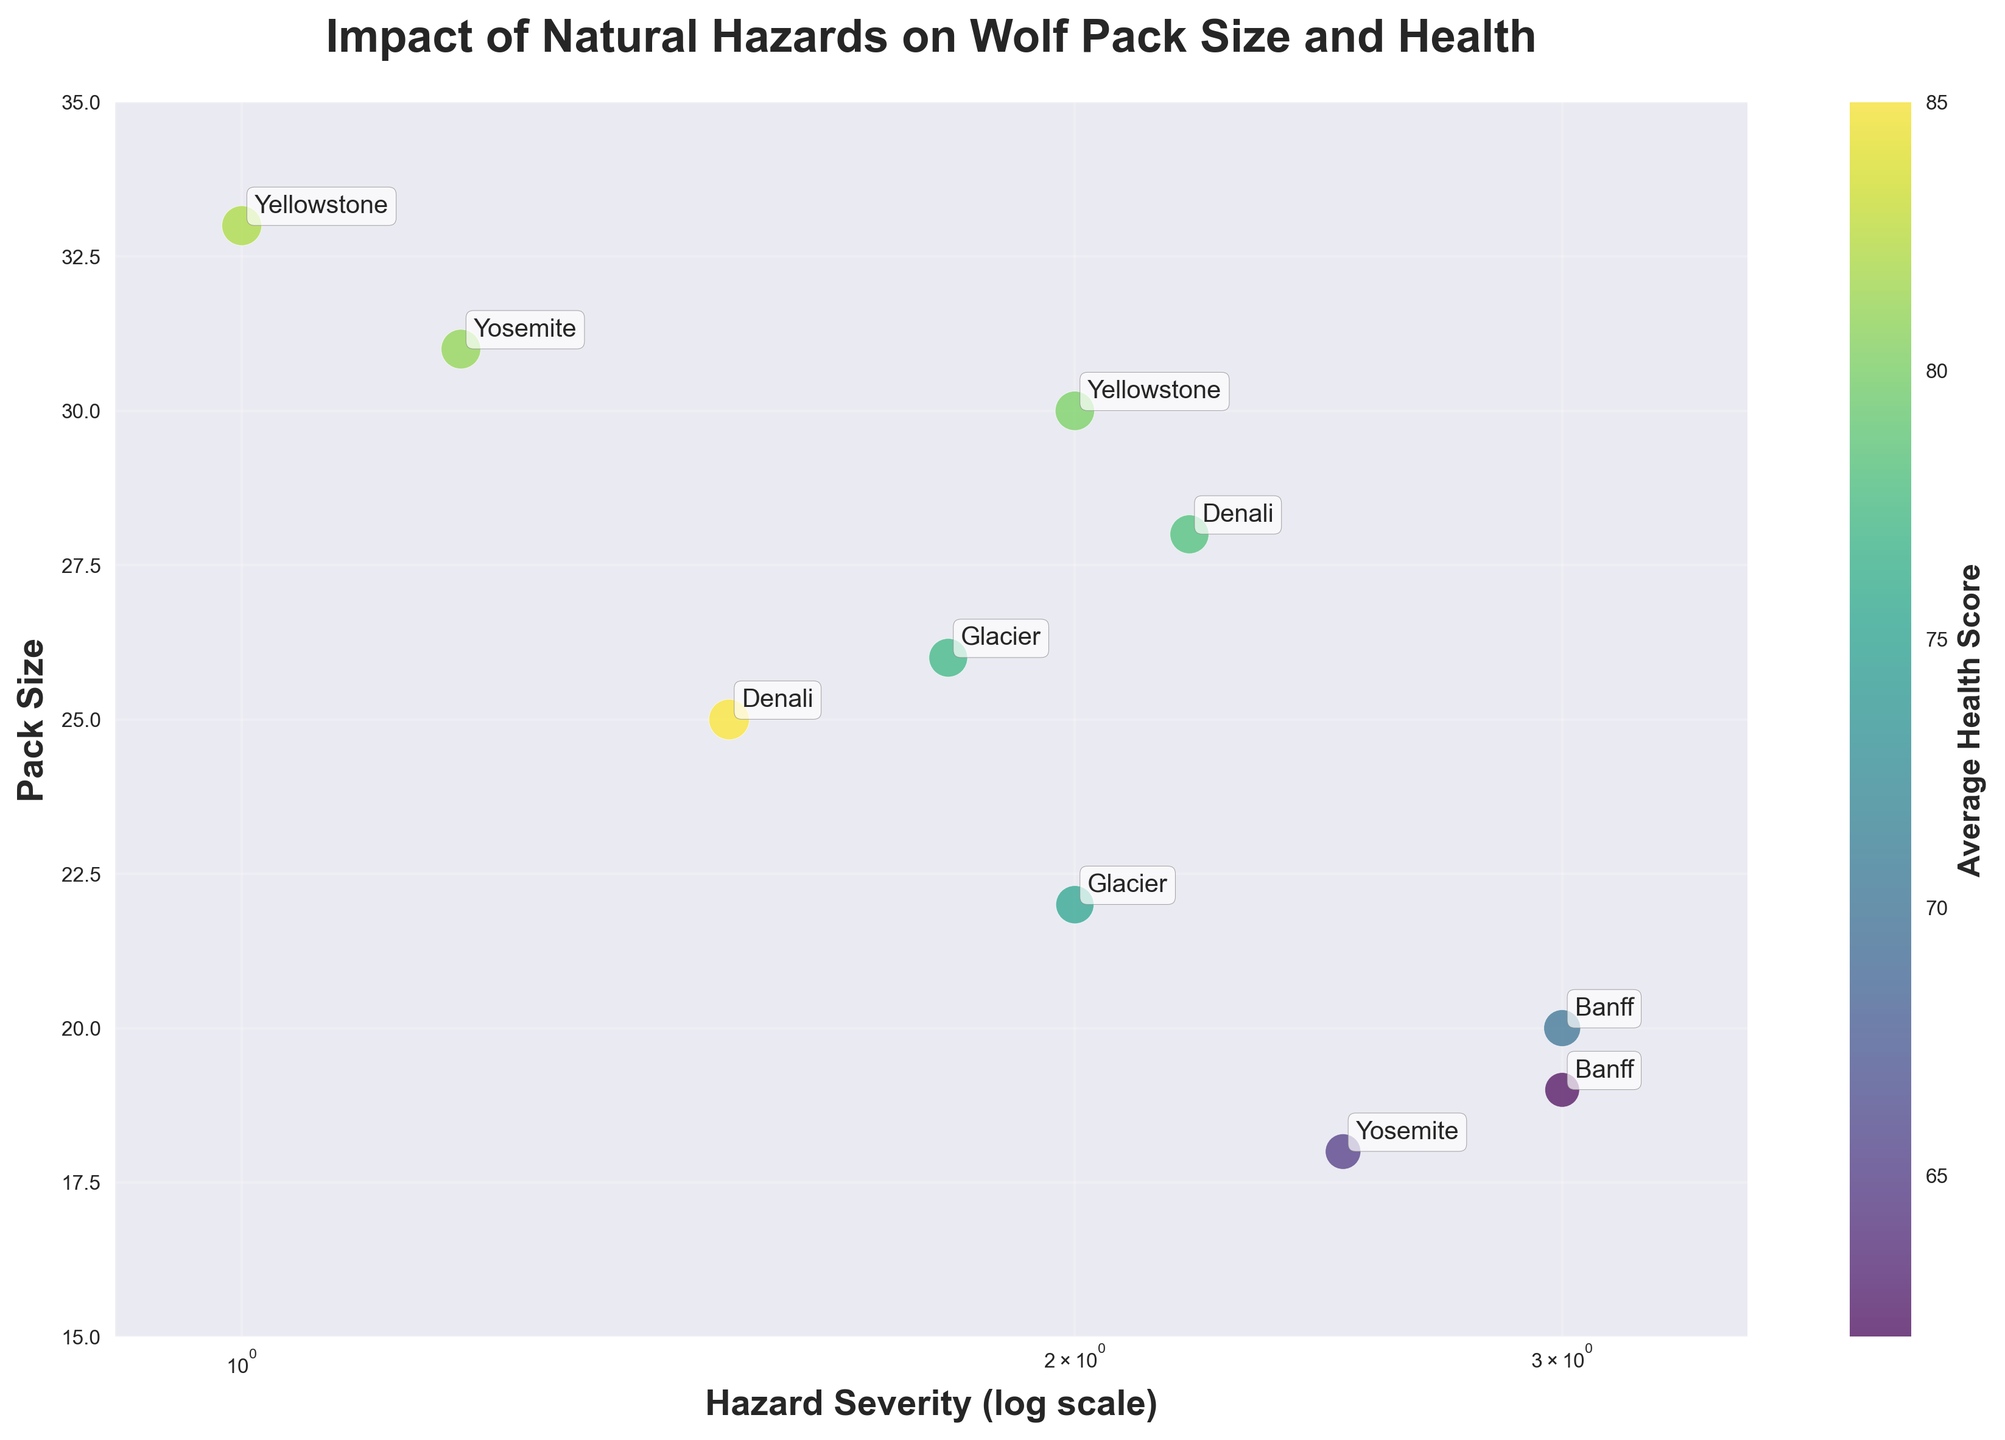How many data points are plotted in the figure? By counting the unique markers in the scatter plot, we can see there are 10 data points.
Answer: 10 Which location experienced the highest severity of hazard? Observing the x-axis (log scale for hazard severity) and finding the farthest point to the right, Banff experienced the highest severity at 3 (Forest Fire).
Answer: Banff What is the trend between hazard severity and pack size? As hazard severity increases along the x-axis (log scale), the pack size shown along the y-axis tends to decrease, indicating a negative correlation.
Answer: Negative correlation Which location had the highest average health score? By examining the color bar and finding the darkest green point, Denali (Flood) with a 1.5 severity has the highest average health score of 85.
Answer: Denali What is the pack size and average health score for the most severe hazard? The point with the highest severity is Banff (Forest Fire, 3), which has a pack size of 20 and an average health score of 70.
Answer: Pack size: 20, Health score: 70 Compare the pack size and health score between Banff and Glacier experiencing flood hazards. Banff (Flood, severity 3) has a pack size of 19 and a health score of 62, while Glacier (Flood, severity 2) has a pack size of 22 and a health score of 75. Therefore, Glacier has larger pack size and better health than Banff.
Answer: Glacier has larger pack size and better health How does the average health score range across different severities? Observing the color of points across severities, it ranges from 62 (darkest color) to 85 (lightest color), corresponding to the data points, indicating a decrease in health score with increased severity.
Answer: Ranges from 62 to 85 What is the average pack size for locations experiencing forest fires? Summing the pack sizes of forest fire locations: 30 (Yellowstone)+20 (Banff)+33 (Yellowstone)+28 (Denali)+26 (Glacier)=137, then dividing by 5 (number of forest fire data points) gives us 137/5 = 27.4.
Answer: 27.4 